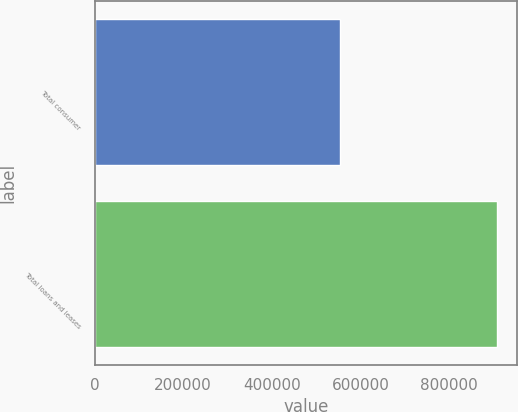<chart> <loc_0><loc_0><loc_500><loc_500><bar_chart><fcel>Total consumer<fcel>Total loans and leases<nl><fcel>553439<fcel>907819<nl></chart> 